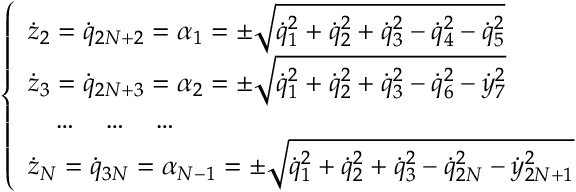Convert formula to latex. <formula><loc_0><loc_0><loc_500><loc_500>\left \{ \begin{array} { l } { { \dot { z } } _ { 2 } = { \dot { q } } _ { 2 N + 2 } = \alpha _ { 1 } = \pm \sqrt { { \dot { q } } _ { 1 } ^ { 2 } + { \dot { q } } _ { 2 } ^ { 2 } + { \dot { q } } _ { 3 } ^ { 2 } - { \dot { q } } _ { 4 } ^ { 2 } - { \dot { q } } _ { 5 } ^ { 2 } } } \\ { { \dot { z } } _ { 3 } = { \dot { q } } _ { 2 N + 3 } = \alpha _ { 2 } = \pm \sqrt { { \dot { q } } _ { 1 } ^ { 2 } + { \dot { q } } _ { 2 } ^ { 2 } + { \dot { q } } _ { 3 } ^ { 2 } - { \dot { q } } _ { 6 } ^ { 2 } - { \dot { y } } _ { 7 } ^ { 2 } } } \\ { \quad \dots \quad \dots \quad \dots } \\ { { \dot { z } } _ { N } = { \dot { q } } _ { 3 N } = \alpha _ { N - 1 } = \pm \sqrt { { \dot { q } } _ { 1 } ^ { 2 } + { \dot { q } } _ { 2 } ^ { 2 } + { \dot { q } } _ { 3 } ^ { 2 } - { \dot { q } } _ { 2 N } ^ { 2 } - { \dot { y } } _ { 2 N + 1 } ^ { 2 } } } \end{array}</formula> 